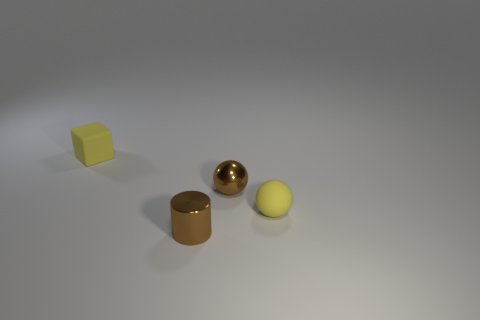What is the color of the rubber object that is in front of the tiny rubber thing that is behind the ball in front of the small brown shiny sphere?
Give a very brief answer. Yellow. Is the color of the small rubber object in front of the yellow rubber cube the same as the small shiny cylinder?
Keep it short and to the point. No. What number of objects are metal things or blue spheres?
Offer a very short reply. 2. What number of objects are brown metal objects or rubber things that are to the left of the cylinder?
Keep it short and to the point. 3. Are the brown sphere and the small brown cylinder made of the same material?
Your answer should be compact. Yes. What number of other things are there of the same material as the brown cylinder
Your answer should be compact. 1. Is the number of brown shiny balls greater than the number of yellow things?
Offer a terse response. No. Are there fewer metallic objects than metal spheres?
Provide a short and direct response. No. There is a yellow sphere that is the same size as the brown cylinder; what material is it?
Offer a very short reply. Rubber. There is a cylinder; does it have the same color as the small sphere behind the rubber sphere?
Provide a short and direct response. Yes. 